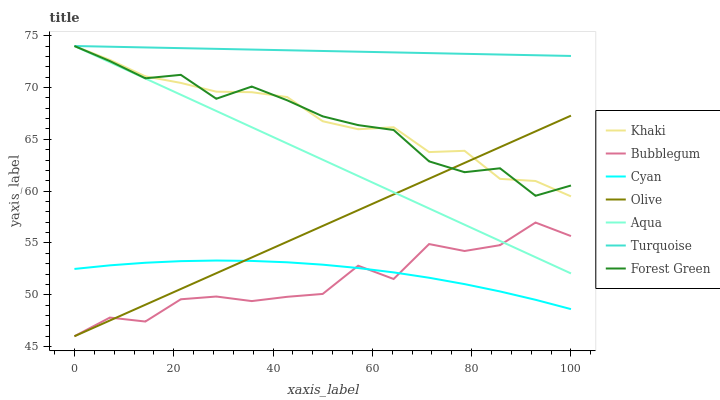Does Bubblegum have the minimum area under the curve?
Answer yes or no. Yes. Does Turquoise have the maximum area under the curve?
Answer yes or no. Yes. Does Khaki have the minimum area under the curve?
Answer yes or no. No. Does Khaki have the maximum area under the curve?
Answer yes or no. No. Is Turquoise the smoothest?
Answer yes or no. Yes. Is Bubblegum the roughest?
Answer yes or no. Yes. Is Khaki the smoothest?
Answer yes or no. No. Is Khaki the roughest?
Answer yes or no. No. Does Khaki have the lowest value?
Answer yes or no. No. Does Forest Green have the highest value?
Answer yes or no. Yes. Does Bubblegum have the highest value?
Answer yes or no. No. Is Cyan less than Turquoise?
Answer yes or no. Yes. Is Forest Green greater than Bubblegum?
Answer yes or no. Yes. Does Khaki intersect Turquoise?
Answer yes or no. Yes. Is Khaki less than Turquoise?
Answer yes or no. No. Is Khaki greater than Turquoise?
Answer yes or no. No. Does Cyan intersect Turquoise?
Answer yes or no. No. 